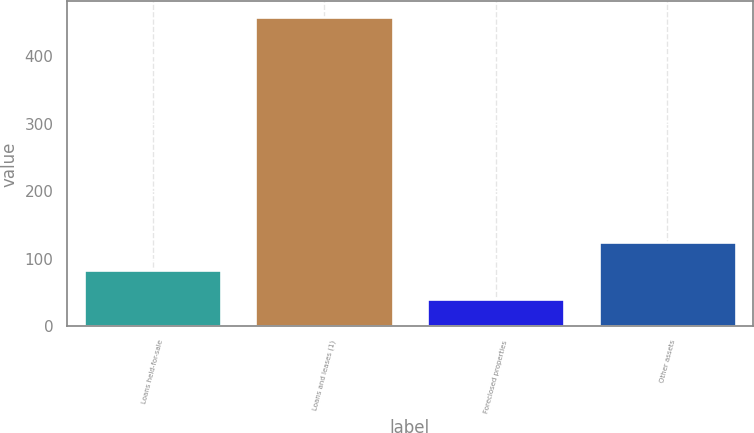Convert chart. <chart><loc_0><loc_0><loc_500><loc_500><bar_chart><fcel>Loans held-for-sale<fcel>Loans and leases (1)<fcel>Foreclosed properties<fcel>Other assets<nl><fcel>82.7<fcel>458<fcel>41<fcel>124.4<nl></chart> 